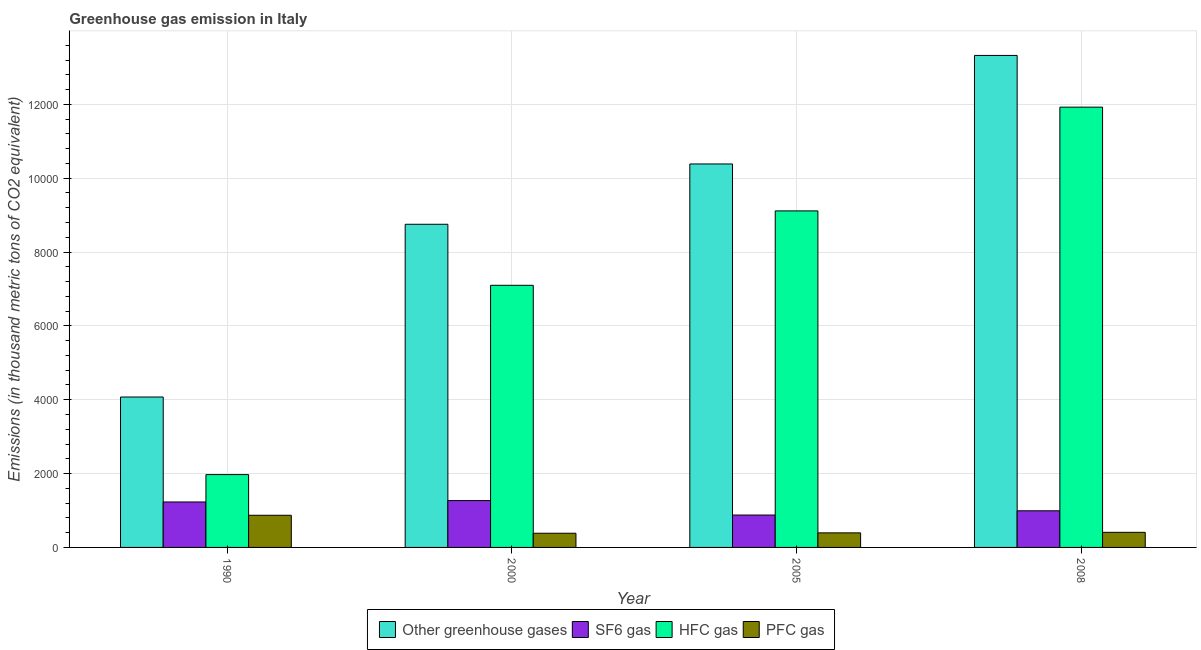How many groups of bars are there?
Provide a short and direct response. 4. Are the number of bars on each tick of the X-axis equal?
Make the answer very short. Yes. How many bars are there on the 3rd tick from the left?
Your answer should be compact. 4. What is the label of the 1st group of bars from the left?
Your response must be concise. 1990. What is the emission of sf6 gas in 1990?
Ensure brevity in your answer.  1230.8. Across all years, what is the maximum emission of greenhouse gases?
Provide a succinct answer. 1.33e+04. Across all years, what is the minimum emission of hfc gas?
Offer a terse response. 1972.2. In which year was the emission of greenhouse gases maximum?
Provide a succinct answer. 2008. In which year was the emission of greenhouse gases minimum?
Give a very brief answer. 1990. What is the total emission of hfc gas in the graph?
Your answer should be compact. 3.01e+04. What is the difference between the emission of sf6 gas in 1990 and that in 2008?
Your answer should be compact. 238.7. What is the average emission of sf6 gas per year?
Keep it short and to the point. 1092.15. In the year 2005, what is the difference between the emission of hfc gas and emission of greenhouse gases?
Your answer should be compact. 0. What is the ratio of the emission of greenhouse gases in 2000 to that in 2005?
Offer a very short reply. 0.84. Is the emission of sf6 gas in 1990 less than that in 2008?
Make the answer very short. No. What is the difference between the highest and the second highest emission of pfc gas?
Give a very brief answer. 462.2. What is the difference between the highest and the lowest emission of hfc gas?
Your response must be concise. 9952.3. Is the sum of the emission of hfc gas in 2000 and 2005 greater than the maximum emission of sf6 gas across all years?
Offer a terse response. Yes. What does the 2nd bar from the left in 2000 represents?
Provide a short and direct response. SF6 gas. What does the 1st bar from the right in 2005 represents?
Your response must be concise. PFC gas. How many years are there in the graph?
Provide a succinct answer. 4. Are the values on the major ticks of Y-axis written in scientific E-notation?
Keep it short and to the point. No. Where does the legend appear in the graph?
Provide a short and direct response. Bottom center. How are the legend labels stacked?
Make the answer very short. Horizontal. What is the title of the graph?
Your answer should be very brief. Greenhouse gas emission in Italy. Does "Secondary general education" appear as one of the legend labels in the graph?
Provide a succinct answer. No. What is the label or title of the Y-axis?
Ensure brevity in your answer.  Emissions (in thousand metric tons of CO2 equivalent). What is the Emissions (in thousand metric tons of CO2 equivalent) of Other greenhouse gases in 1990?
Offer a terse response. 4074. What is the Emissions (in thousand metric tons of CO2 equivalent) in SF6 gas in 1990?
Your response must be concise. 1230.8. What is the Emissions (in thousand metric tons of CO2 equivalent) of HFC gas in 1990?
Your response must be concise. 1972.2. What is the Emissions (in thousand metric tons of CO2 equivalent) in PFC gas in 1990?
Your response must be concise. 871. What is the Emissions (in thousand metric tons of CO2 equivalent) of Other greenhouse gases in 2000?
Make the answer very short. 8752.3. What is the Emissions (in thousand metric tons of CO2 equivalent) in SF6 gas in 2000?
Offer a very short reply. 1268.5. What is the Emissions (in thousand metric tons of CO2 equivalent) of HFC gas in 2000?
Keep it short and to the point. 7099.5. What is the Emissions (in thousand metric tons of CO2 equivalent) in PFC gas in 2000?
Make the answer very short. 384.3. What is the Emissions (in thousand metric tons of CO2 equivalent) in Other greenhouse gases in 2005?
Your response must be concise. 1.04e+04. What is the Emissions (in thousand metric tons of CO2 equivalent) in SF6 gas in 2005?
Offer a very short reply. 877.2. What is the Emissions (in thousand metric tons of CO2 equivalent) of HFC gas in 2005?
Your answer should be very brief. 9114.5. What is the Emissions (in thousand metric tons of CO2 equivalent) in PFC gas in 2005?
Provide a short and direct response. 394.3. What is the Emissions (in thousand metric tons of CO2 equivalent) of Other greenhouse gases in 2008?
Offer a very short reply. 1.33e+04. What is the Emissions (in thousand metric tons of CO2 equivalent) in SF6 gas in 2008?
Give a very brief answer. 992.1. What is the Emissions (in thousand metric tons of CO2 equivalent) in HFC gas in 2008?
Your answer should be compact. 1.19e+04. What is the Emissions (in thousand metric tons of CO2 equivalent) of PFC gas in 2008?
Make the answer very short. 408.8. Across all years, what is the maximum Emissions (in thousand metric tons of CO2 equivalent) of Other greenhouse gases?
Offer a very short reply. 1.33e+04. Across all years, what is the maximum Emissions (in thousand metric tons of CO2 equivalent) of SF6 gas?
Make the answer very short. 1268.5. Across all years, what is the maximum Emissions (in thousand metric tons of CO2 equivalent) in HFC gas?
Offer a terse response. 1.19e+04. Across all years, what is the maximum Emissions (in thousand metric tons of CO2 equivalent) in PFC gas?
Offer a very short reply. 871. Across all years, what is the minimum Emissions (in thousand metric tons of CO2 equivalent) of Other greenhouse gases?
Keep it short and to the point. 4074. Across all years, what is the minimum Emissions (in thousand metric tons of CO2 equivalent) in SF6 gas?
Your answer should be compact. 877.2. Across all years, what is the minimum Emissions (in thousand metric tons of CO2 equivalent) of HFC gas?
Offer a terse response. 1972.2. Across all years, what is the minimum Emissions (in thousand metric tons of CO2 equivalent) in PFC gas?
Provide a succinct answer. 384.3. What is the total Emissions (in thousand metric tons of CO2 equivalent) of Other greenhouse gases in the graph?
Give a very brief answer. 3.65e+04. What is the total Emissions (in thousand metric tons of CO2 equivalent) in SF6 gas in the graph?
Provide a succinct answer. 4368.6. What is the total Emissions (in thousand metric tons of CO2 equivalent) in HFC gas in the graph?
Make the answer very short. 3.01e+04. What is the total Emissions (in thousand metric tons of CO2 equivalent) in PFC gas in the graph?
Offer a very short reply. 2058.4. What is the difference between the Emissions (in thousand metric tons of CO2 equivalent) in Other greenhouse gases in 1990 and that in 2000?
Your answer should be very brief. -4678.3. What is the difference between the Emissions (in thousand metric tons of CO2 equivalent) of SF6 gas in 1990 and that in 2000?
Keep it short and to the point. -37.7. What is the difference between the Emissions (in thousand metric tons of CO2 equivalent) in HFC gas in 1990 and that in 2000?
Make the answer very short. -5127.3. What is the difference between the Emissions (in thousand metric tons of CO2 equivalent) in PFC gas in 1990 and that in 2000?
Offer a very short reply. 486.7. What is the difference between the Emissions (in thousand metric tons of CO2 equivalent) of Other greenhouse gases in 1990 and that in 2005?
Your answer should be compact. -6312. What is the difference between the Emissions (in thousand metric tons of CO2 equivalent) of SF6 gas in 1990 and that in 2005?
Your answer should be very brief. 353.6. What is the difference between the Emissions (in thousand metric tons of CO2 equivalent) of HFC gas in 1990 and that in 2005?
Offer a terse response. -7142.3. What is the difference between the Emissions (in thousand metric tons of CO2 equivalent) in PFC gas in 1990 and that in 2005?
Your response must be concise. 476.7. What is the difference between the Emissions (in thousand metric tons of CO2 equivalent) of Other greenhouse gases in 1990 and that in 2008?
Give a very brief answer. -9251.4. What is the difference between the Emissions (in thousand metric tons of CO2 equivalent) of SF6 gas in 1990 and that in 2008?
Provide a succinct answer. 238.7. What is the difference between the Emissions (in thousand metric tons of CO2 equivalent) of HFC gas in 1990 and that in 2008?
Your answer should be compact. -9952.3. What is the difference between the Emissions (in thousand metric tons of CO2 equivalent) in PFC gas in 1990 and that in 2008?
Provide a succinct answer. 462.2. What is the difference between the Emissions (in thousand metric tons of CO2 equivalent) in Other greenhouse gases in 2000 and that in 2005?
Give a very brief answer. -1633.7. What is the difference between the Emissions (in thousand metric tons of CO2 equivalent) of SF6 gas in 2000 and that in 2005?
Offer a terse response. 391.3. What is the difference between the Emissions (in thousand metric tons of CO2 equivalent) in HFC gas in 2000 and that in 2005?
Provide a short and direct response. -2015. What is the difference between the Emissions (in thousand metric tons of CO2 equivalent) of Other greenhouse gases in 2000 and that in 2008?
Keep it short and to the point. -4573.1. What is the difference between the Emissions (in thousand metric tons of CO2 equivalent) in SF6 gas in 2000 and that in 2008?
Give a very brief answer. 276.4. What is the difference between the Emissions (in thousand metric tons of CO2 equivalent) of HFC gas in 2000 and that in 2008?
Ensure brevity in your answer.  -4825. What is the difference between the Emissions (in thousand metric tons of CO2 equivalent) of PFC gas in 2000 and that in 2008?
Offer a very short reply. -24.5. What is the difference between the Emissions (in thousand metric tons of CO2 equivalent) of Other greenhouse gases in 2005 and that in 2008?
Keep it short and to the point. -2939.4. What is the difference between the Emissions (in thousand metric tons of CO2 equivalent) in SF6 gas in 2005 and that in 2008?
Provide a short and direct response. -114.9. What is the difference between the Emissions (in thousand metric tons of CO2 equivalent) of HFC gas in 2005 and that in 2008?
Your answer should be very brief. -2810. What is the difference between the Emissions (in thousand metric tons of CO2 equivalent) of PFC gas in 2005 and that in 2008?
Provide a succinct answer. -14.5. What is the difference between the Emissions (in thousand metric tons of CO2 equivalent) of Other greenhouse gases in 1990 and the Emissions (in thousand metric tons of CO2 equivalent) of SF6 gas in 2000?
Your answer should be compact. 2805.5. What is the difference between the Emissions (in thousand metric tons of CO2 equivalent) of Other greenhouse gases in 1990 and the Emissions (in thousand metric tons of CO2 equivalent) of HFC gas in 2000?
Keep it short and to the point. -3025.5. What is the difference between the Emissions (in thousand metric tons of CO2 equivalent) of Other greenhouse gases in 1990 and the Emissions (in thousand metric tons of CO2 equivalent) of PFC gas in 2000?
Your response must be concise. 3689.7. What is the difference between the Emissions (in thousand metric tons of CO2 equivalent) of SF6 gas in 1990 and the Emissions (in thousand metric tons of CO2 equivalent) of HFC gas in 2000?
Provide a short and direct response. -5868.7. What is the difference between the Emissions (in thousand metric tons of CO2 equivalent) of SF6 gas in 1990 and the Emissions (in thousand metric tons of CO2 equivalent) of PFC gas in 2000?
Your answer should be compact. 846.5. What is the difference between the Emissions (in thousand metric tons of CO2 equivalent) in HFC gas in 1990 and the Emissions (in thousand metric tons of CO2 equivalent) in PFC gas in 2000?
Make the answer very short. 1587.9. What is the difference between the Emissions (in thousand metric tons of CO2 equivalent) of Other greenhouse gases in 1990 and the Emissions (in thousand metric tons of CO2 equivalent) of SF6 gas in 2005?
Offer a very short reply. 3196.8. What is the difference between the Emissions (in thousand metric tons of CO2 equivalent) in Other greenhouse gases in 1990 and the Emissions (in thousand metric tons of CO2 equivalent) in HFC gas in 2005?
Your answer should be compact. -5040.5. What is the difference between the Emissions (in thousand metric tons of CO2 equivalent) of Other greenhouse gases in 1990 and the Emissions (in thousand metric tons of CO2 equivalent) of PFC gas in 2005?
Your response must be concise. 3679.7. What is the difference between the Emissions (in thousand metric tons of CO2 equivalent) in SF6 gas in 1990 and the Emissions (in thousand metric tons of CO2 equivalent) in HFC gas in 2005?
Make the answer very short. -7883.7. What is the difference between the Emissions (in thousand metric tons of CO2 equivalent) of SF6 gas in 1990 and the Emissions (in thousand metric tons of CO2 equivalent) of PFC gas in 2005?
Your answer should be compact. 836.5. What is the difference between the Emissions (in thousand metric tons of CO2 equivalent) in HFC gas in 1990 and the Emissions (in thousand metric tons of CO2 equivalent) in PFC gas in 2005?
Give a very brief answer. 1577.9. What is the difference between the Emissions (in thousand metric tons of CO2 equivalent) of Other greenhouse gases in 1990 and the Emissions (in thousand metric tons of CO2 equivalent) of SF6 gas in 2008?
Ensure brevity in your answer.  3081.9. What is the difference between the Emissions (in thousand metric tons of CO2 equivalent) of Other greenhouse gases in 1990 and the Emissions (in thousand metric tons of CO2 equivalent) of HFC gas in 2008?
Provide a succinct answer. -7850.5. What is the difference between the Emissions (in thousand metric tons of CO2 equivalent) of Other greenhouse gases in 1990 and the Emissions (in thousand metric tons of CO2 equivalent) of PFC gas in 2008?
Offer a terse response. 3665.2. What is the difference between the Emissions (in thousand metric tons of CO2 equivalent) in SF6 gas in 1990 and the Emissions (in thousand metric tons of CO2 equivalent) in HFC gas in 2008?
Your answer should be very brief. -1.07e+04. What is the difference between the Emissions (in thousand metric tons of CO2 equivalent) in SF6 gas in 1990 and the Emissions (in thousand metric tons of CO2 equivalent) in PFC gas in 2008?
Ensure brevity in your answer.  822. What is the difference between the Emissions (in thousand metric tons of CO2 equivalent) of HFC gas in 1990 and the Emissions (in thousand metric tons of CO2 equivalent) of PFC gas in 2008?
Provide a succinct answer. 1563.4. What is the difference between the Emissions (in thousand metric tons of CO2 equivalent) in Other greenhouse gases in 2000 and the Emissions (in thousand metric tons of CO2 equivalent) in SF6 gas in 2005?
Give a very brief answer. 7875.1. What is the difference between the Emissions (in thousand metric tons of CO2 equivalent) in Other greenhouse gases in 2000 and the Emissions (in thousand metric tons of CO2 equivalent) in HFC gas in 2005?
Offer a very short reply. -362.2. What is the difference between the Emissions (in thousand metric tons of CO2 equivalent) of Other greenhouse gases in 2000 and the Emissions (in thousand metric tons of CO2 equivalent) of PFC gas in 2005?
Your answer should be very brief. 8358. What is the difference between the Emissions (in thousand metric tons of CO2 equivalent) of SF6 gas in 2000 and the Emissions (in thousand metric tons of CO2 equivalent) of HFC gas in 2005?
Your answer should be compact. -7846. What is the difference between the Emissions (in thousand metric tons of CO2 equivalent) of SF6 gas in 2000 and the Emissions (in thousand metric tons of CO2 equivalent) of PFC gas in 2005?
Provide a short and direct response. 874.2. What is the difference between the Emissions (in thousand metric tons of CO2 equivalent) in HFC gas in 2000 and the Emissions (in thousand metric tons of CO2 equivalent) in PFC gas in 2005?
Provide a succinct answer. 6705.2. What is the difference between the Emissions (in thousand metric tons of CO2 equivalent) of Other greenhouse gases in 2000 and the Emissions (in thousand metric tons of CO2 equivalent) of SF6 gas in 2008?
Your answer should be compact. 7760.2. What is the difference between the Emissions (in thousand metric tons of CO2 equivalent) of Other greenhouse gases in 2000 and the Emissions (in thousand metric tons of CO2 equivalent) of HFC gas in 2008?
Your answer should be compact. -3172.2. What is the difference between the Emissions (in thousand metric tons of CO2 equivalent) of Other greenhouse gases in 2000 and the Emissions (in thousand metric tons of CO2 equivalent) of PFC gas in 2008?
Provide a short and direct response. 8343.5. What is the difference between the Emissions (in thousand metric tons of CO2 equivalent) in SF6 gas in 2000 and the Emissions (in thousand metric tons of CO2 equivalent) in HFC gas in 2008?
Offer a terse response. -1.07e+04. What is the difference between the Emissions (in thousand metric tons of CO2 equivalent) in SF6 gas in 2000 and the Emissions (in thousand metric tons of CO2 equivalent) in PFC gas in 2008?
Provide a succinct answer. 859.7. What is the difference between the Emissions (in thousand metric tons of CO2 equivalent) in HFC gas in 2000 and the Emissions (in thousand metric tons of CO2 equivalent) in PFC gas in 2008?
Provide a succinct answer. 6690.7. What is the difference between the Emissions (in thousand metric tons of CO2 equivalent) in Other greenhouse gases in 2005 and the Emissions (in thousand metric tons of CO2 equivalent) in SF6 gas in 2008?
Provide a short and direct response. 9393.9. What is the difference between the Emissions (in thousand metric tons of CO2 equivalent) in Other greenhouse gases in 2005 and the Emissions (in thousand metric tons of CO2 equivalent) in HFC gas in 2008?
Offer a terse response. -1538.5. What is the difference between the Emissions (in thousand metric tons of CO2 equivalent) in Other greenhouse gases in 2005 and the Emissions (in thousand metric tons of CO2 equivalent) in PFC gas in 2008?
Your answer should be very brief. 9977.2. What is the difference between the Emissions (in thousand metric tons of CO2 equivalent) of SF6 gas in 2005 and the Emissions (in thousand metric tons of CO2 equivalent) of HFC gas in 2008?
Offer a terse response. -1.10e+04. What is the difference between the Emissions (in thousand metric tons of CO2 equivalent) of SF6 gas in 2005 and the Emissions (in thousand metric tons of CO2 equivalent) of PFC gas in 2008?
Offer a terse response. 468.4. What is the difference between the Emissions (in thousand metric tons of CO2 equivalent) in HFC gas in 2005 and the Emissions (in thousand metric tons of CO2 equivalent) in PFC gas in 2008?
Offer a terse response. 8705.7. What is the average Emissions (in thousand metric tons of CO2 equivalent) in Other greenhouse gases per year?
Provide a short and direct response. 9134.42. What is the average Emissions (in thousand metric tons of CO2 equivalent) of SF6 gas per year?
Offer a very short reply. 1092.15. What is the average Emissions (in thousand metric tons of CO2 equivalent) in HFC gas per year?
Give a very brief answer. 7527.68. What is the average Emissions (in thousand metric tons of CO2 equivalent) in PFC gas per year?
Keep it short and to the point. 514.6. In the year 1990, what is the difference between the Emissions (in thousand metric tons of CO2 equivalent) of Other greenhouse gases and Emissions (in thousand metric tons of CO2 equivalent) of SF6 gas?
Ensure brevity in your answer.  2843.2. In the year 1990, what is the difference between the Emissions (in thousand metric tons of CO2 equivalent) in Other greenhouse gases and Emissions (in thousand metric tons of CO2 equivalent) in HFC gas?
Your answer should be compact. 2101.8. In the year 1990, what is the difference between the Emissions (in thousand metric tons of CO2 equivalent) in Other greenhouse gases and Emissions (in thousand metric tons of CO2 equivalent) in PFC gas?
Make the answer very short. 3203. In the year 1990, what is the difference between the Emissions (in thousand metric tons of CO2 equivalent) in SF6 gas and Emissions (in thousand metric tons of CO2 equivalent) in HFC gas?
Make the answer very short. -741.4. In the year 1990, what is the difference between the Emissions (in thousand metric tons of CO2 equivalent) in SF6 gas and Emissions (in thousand metric tons of CO2 equivalent) in PFC gas?
Ensure brevity in your answer.  359.8. In the year 1990, what is the difference between the Emissions (in thousand metric tons of CO2 equivalent) in HFC gas and Emissions (in thousand metric tons of CO2 equivalent) in PFC gas?
Keep it short and to the point. 1101.2. In the year 2000, what is the difference between the Emissions (in thousand metric tons of CO2 equivalent) of Other greenhouse gases and Emissions (in thousand metric tons of CO2 equivalent) of SF6 gas?
Your answer should be very brief. 7483.8. In the year 2000, what is the difference between the Emissions (in thousand metric tons of CO2 equivalent) in Other greenhouse gases and Emissions (in thousand metric tons of CO2 equivalent) in HFC gas?
Keep it short and to the point. 1652.8. In the year 2000, what is the difference between the Emissions (in thousand metric tons of CO2 equivalent) in Other greenhouse gases and Emissions (in thousand metric tons of CO2 equivalent) in PFC gas?
Offer a terse response. 8368. In the year 2000, what is the difference between the Emissions (in thousand metric tons of CO2 equivalent) of SF6 gas and Emissions (in thousand metric tons of CO2 equivalent) of HFC gas?
Your answer should be compact. -5831. In the year 2000, what is the difference between the Emissions (in thousand metric tons of CO2 equivalent) of SF6 gas and Emissions (in thousand metric tons of CO2 equivalent) of PFC gas?
Offer a very short reply. 884.2. In the year 2000, what is the difference between the Emissions (in thousand metric tons of CO2 equivalent) of HFC gas and Emissions (in thousand metric tons of CO2 equivalent) of PFC gas?
Make the answer very short. 6715.2. In the year 2005, what is the difference between the Emissions (in thousand metric tons of CO2 equivalent) of Other greenhouse gases and Emissions (in thousand metric tons of CO2 equivalent) of SF6 gas?
Your answer should be compact. 9508.8. In the year 2005, what is the difference between the Emissions (in thousand metric tons of CO2 equivalent) in Other greenhouse gases and Emissions (in thousand metric tons of CO2 equivalent) in HFC gas?
Provide a succinct answer. 1271.5. In the year 2005, what is the difference between the Emissions (in thousand metric tons of CO2 equivalent) of Other greenhouse gases and Emissions (in thousand metric tons of CO2 equivalent) of PFC gas?
Provide a short and direct response. 9991.7. In the year 2005, what is the difference between the Emissions (in thousand metric tons of CO2 equivalent) in SF6 gas and Emissions (in thousand metric tons of CO2 equivalent) in HFC gas?
Your answer should be compact. -8237.3. In the year 2005, what is the difference between the Emissions (in thousand metric tons of CO2 equivalent) in SF6 gas and Emissions (in thousand metric tons of CO2 equivalent) in PFC gas?
Keep it short and to the point. 482.9. In the year 2005, what is the difference between the Emissions (in thousand metric tons of CO2 equivalent) of HFC gas and Emissions (in thousand metric tons of CO2 equivalent) of PFC gas?
Give a very brief answer. 8720.2. In the year 2008, what is the difference between the Emissions (in thousand metric tons of CO2 equivalent) of Other greenhouse gases and Emissions (in thousand metric tons of CO2 equivalent) of SF6 gas?
Ensure brevity in your answer.  1.23e+04. In the year 2008, what is the difference between the Emissions (in thousand metric tons of CO2 equivalent) of Other greenhouse gases and Emissions (in thousand metric tons of CO2 equivalent) of HFC gas?
Your response must be concise. 1400.9. In the year 2008, what is the difference between the Emissions (in thousand metric tons of CO2 equivalent) in Other greenhouse gases and Emissions (in thousand metric tons of CO2 equivalent) in PFC gas?
Your answer should be very brief. 1.29e+04. In the year 2008, what is the difference between the Emissions (in thousand metric tons of CO2 equivalent) in SF6 gas and Emissions (in thousand metric tons of CO2 equivalent) in HFC gas?
Your answer should be compact. -1.09e+04. In the year 2008, what is the difference between the Emissions (in thousand metric tons of CO2 equivalent) in SF6 gas and Emissions (in thousand metric tons of CO2 equivalent) in PFC gas?
Give a very brief answer. 583.3. In the year 2008, what is the difference between the Emissions (in thousand metric tons of CO2 equivalent) in HFC gas and Emissions (in thousand metric tons of CO2 equivalent) in PFC gas?
Offer a terse response. 1.15e+04. What is the ratio of the Emissions (in thousand metric tons of CO2 equivalent) in Other greenhouse gases in 1990 to that in 2000?
Offer a terse response. 0.47. What is the ratio of the Emissions (in thousand metric tons of CO2 equivalent) of SF6 gas in 1990 to that in 2000?
Your answer should be compact. 0.97. What is the ratio of the Emissions (in thousand metric tons of CO2 equivalent) of HFC gas in 1990 to that in 2000?
Make the answer very short. 0.28. What is the ratio of the Emissions (in thousand metric tons of CO2 equivalent) in PFC gas in 1990 to that in 2000?
Provide a succinct answer. 2.27. What is the ratio of the Emissions (in thousand metric tons of CO2 equivalent) of Other greenhouse gases in 1990 to that in 2005?
Make the answer very short. 0.39. What is the ratio of the Emissions (in thousand metric tons of CO2 equivalent) of SF6 gas in 1990 to that in 2005?
Give a very brief answer. 1.4. What is the ratio of the Emissions (in thousand metric tons of CO2 equivalent) in HFC gas in 1990 to that in 2005?
Give a very brief answer. 0.22. What is the ratio of the Emissions (in thousand metric tons of CO2 equivalent) of PFC gas in 1990 to that in 2005?
Ensure brevity in your answer.  2.21. What is the ratio of the Emissions (in thousand metric tons of CO2 equivalent) of Other greenhouse gases in 1990 to that in 2008?
Your response must be concise. 0.31. What is the ratio of the Emissions (in thousand metric tons of CO2 equivalent) of SF6 gas in 1990 to that in 2008?
Provide a succinct answer. 1.24. What is the ratio of the Emissions (in thousand metric tons of CO2 equivalent) in HFC gas in 1990 to that in 2008?
Give a very brief answer. 0.17. What is the ratio of the Emissions (in thousand metric tons of CO2 equivalent) of PFC gas in 1990 to that in 2008?
Keep it short and to the point. 2.13. What is the ratio of the Emissions (in thousand metric tons of CO2 equivalent) in Other greenhouse gases in 2000 to that in 2005?
Ensure brevity in your answer.  0.84. What is the ratio of the Emissions (in thousand metric tons of CO2 equivalent) in SF6 gas in 2000 to that in 2005?
Provide a short and direct response. 1.45. What is the ratio of the Emissions (in thousand metric tons of CO2 equivalent) in HFC gas in 2000 to that in 2005?
Provide a short and direct response. 0.78. What is the ratio of the Emissions (in thousand metric tons of CO2 equivalent) in PFC gas in 2000 to that in 2005?
Your answer should be compact. 0.97. What is the ratio of the Emissions (in thousand metric tons of CO2 equivalent) in Other greenhouse gases in 2000 to that in 2008?
Make the answer very short. 0.66. What is the ratio of the Emissions (in thousand metric tons of CO2 equivalent) of SF6 gas in 2000 to that in 2008?
Your answer should be compact. 1.28. What is the ratio of the Emissions (in thousand metric tons of CO2 equivalent) of HFC gas in 2000 to that in 2008?
Offer a terse response. 0.6. What is the ratio of the Emissions (in thousand metric tons of CO2 equivalent) in PFC gas in 2000 to that in 2008?
Provide a short and direct response. 0.94. What is the ratio of the Emissions (in thousand metric tons of CO2 equivalent) in Other greenhouse gases in 2005 to that in 2008?
Make the answer very short. 0.78. What is the ratio of the Emissions (in thousand metric tons of CO2 equivalent) in SF6 gas in 2005 to that in 2008?
Ensure brevity in your answer.  0.88. What is the ratio of the Emissions (in thousand metric tons of CO2 equivalent) of HFC gas in 2005 to that in 2008?
Ensure brevity in your answer.  0.76. What is the ratio of the Emissions (in thousand metric tons of CO2 equivalent) in PFC gas in 2005 to that in 2008?
Provide a succinct answer. 0.96. What is the difference between the highest and the second highest Emissions (in thousand metric tons of CO2 equivalent) of Other greenhouse gases?
Your response must be concise. 2939.4. What is the difference between the highest and the second highest Emissions (in thousand metric tons of CO2 equivalent) of SF6 gas?
Provide a short and direct response. 37.7. What is the difference between the highest and the second highest Emissions (in thousand metric tons of CO2 equivalent) in HFC gas?
Keep it short and to the point. 2810. What is the difference between the highest and the second highest Emissions (in thousand metric tons of CO2 equivalent) in PFC gas?
Your response must be concise. 462.2. What is the difference between the highest and the lowest Emissions (in thousand metric tons of CO2 equivalent) of Other greenhouse gases?
Your answer should be compact. 9251.4. What is the difference between the highest and the lowest Emissions (in thousand metric tons of CO2 equivalent) in SF6 gas?
Your response must be concise. 391.3. What is the difference between the highest and the lowest Emissions (in thousand metric tons of CO2 equivalent) in HFC gas?
Offer a terse response. 9952.3. What is the difference between the highest and the lowest Emissions (in thousand metric tons of CO2 equivalent) in PFC gas?
Offer a terse response. 486.7. 